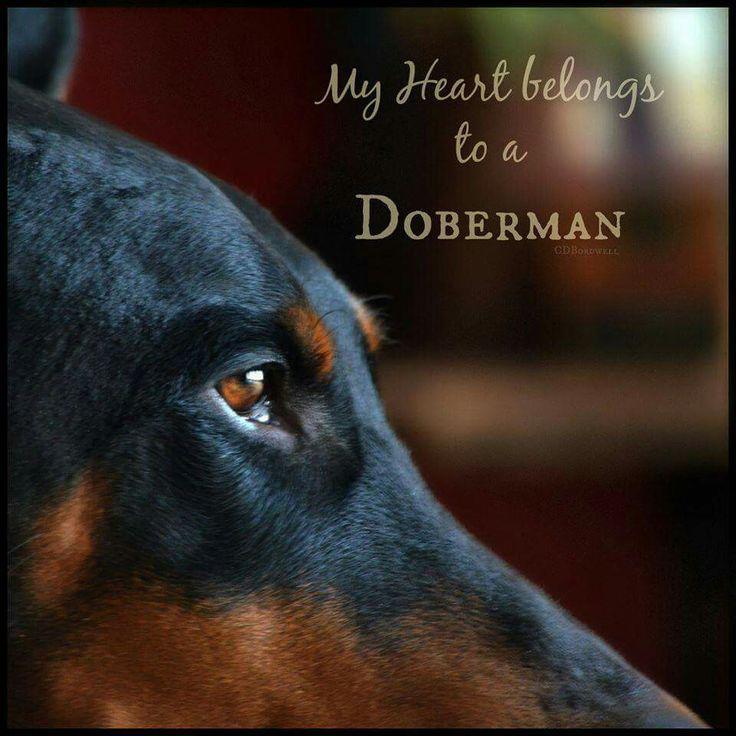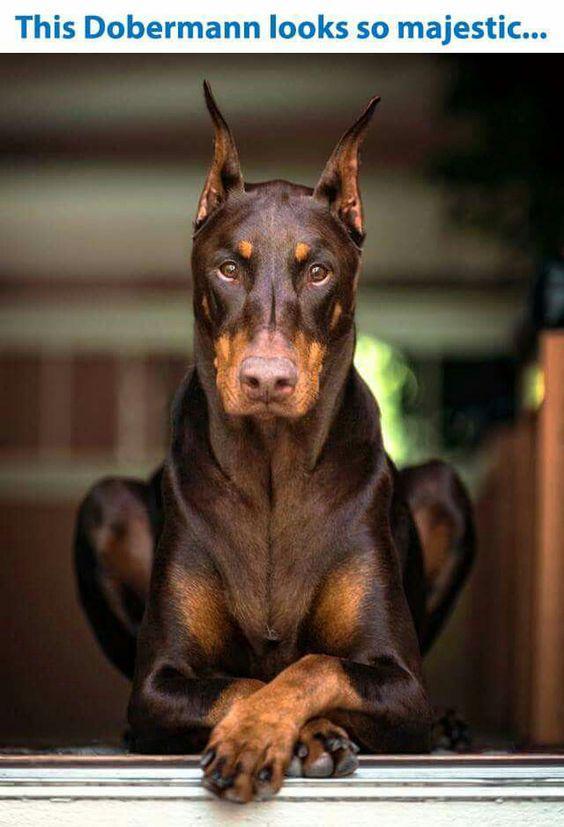The first image is the image on the left, the second image is the image on the right. Considering the images on both sides, is "The doberman on the left has upright ears and wears a collar, and the doberman on the right has floppy ears and no collar." valid? Answer yes or no. No. The first image is the image on the left, the second image is the image on the right. Given the left and right images, does the statement "The dog in the image on the left is wearing a collar." hold true? Answer yes or no. No. 